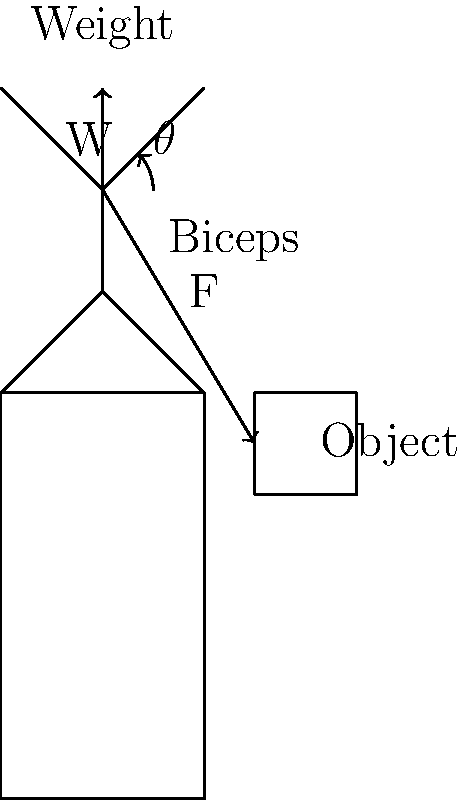In the context of network load balancing, consider the biomechanical analogy of lifting an object. If the biceps muscle generates a force F at an angle $\theta$ to the vertical, and the weight of the object is W, what is the magnitude of F required to hold the object stationary, in terms of W and $\theta$? To solve this problem, we'll use principles of biomechanics that can be analogous to load balancing in networks:

1. Identify the forces: 
   - Weight of the object (W) acting vertically downward
   - Force exerted by the biceps muscle (F) at an angle $\theta$ to the vertical

2. For the object to remain stationary, the sum of vertical forces must be zero:
   $F_y - W = 0$, where $F_y$ is the vertical component of F

3. The vertical component of F is given by:
   $F_y = F \cos(\theta)$

4. Substituting this into the force balance equation:
   $F \cos(\theta) - W = 0$

5. Solving for F:
   $F \cos(\theta) = W$
   $F = \frac{W}{\cos(\theta)}$

This result shows that as $\theta$ increases (the arm moves further from vertical), a larger force F is required to hold the same weight, similar to how network load increases with suboptimal resource allocation.
Answer: $F = \frac{W}{\cos(\theta)}$ 